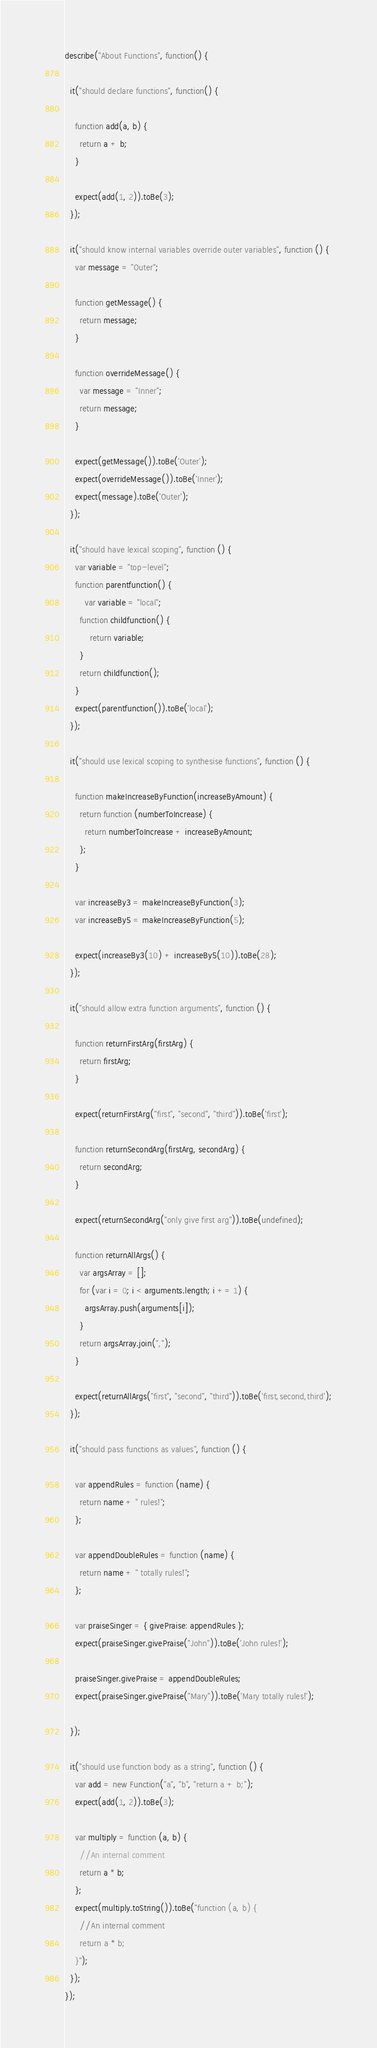Convert code to text. <code><loc_0><loc_0><loc_500><loc_500><_JavaScript_>describe("About Functions", function() {

  it("should declare functions", function() {
    
    function add(a, b) {
      return a + b;
    }
    
    expect(add(1, 2)).toBe(3);
  });

  it("should know internal variables override outer variables", function () {
    var message = "Outer";
    
    function getMessage() {
      return message;
    }
    
    function overrideMessage() {
      var message = "Inner";
      return message;
    }
    
    expect(getMessage()).toBe('Outer');
    expect(overrideMessage()).toBe('Inner');
    expect(message).toBe('Outer');
  });

  it("should have lexical scoping", function () {
    var variable = "top-level";
    function parentfunction() {
        var variable = "local";
      function childfunction() {
          return variable;
      }
      return childfunction();
    }
    expect(parentfunction()).toBe('local');
  });

  it("should use lexical scoping to synthesise functions", function () {
    
    function makeIncreaseByFunction(increaseByAmount) {
      return function (numberToIncrease) {
        return numberToIncrease + increaseByAmount;
      };
    }
    
    var increaseBy3 = makeIncreaseByFunction(3);
    var increaseBy5 = makeIncreaseByFunction(5);
    
    expect(increaseBy3(10) + increaseBy5(10)).toBe(28);
  });

  it("should allow extra function arguments", function () {
    
    function returnFirstArg(firstArg) {
      return firstArg;
    }
    
    expect(returnFirstArg("first", "second", "third")).toBe('first');
    
    function returnSecondArg(firstArg, secondArg) {
      return secondArg;
    }
    
    expect(returnSecondArg("only give first arg")).toBe(undefined);
    
    function returnAllArgs() {
      var argsArray = [];
      for (var i = 0; i < arguments.length; i += 1) {
        argsArray.push(arguments[i]);
      }
      return argsArray.join(",");
    }
    
    expect(returnAllArgs("first", "second", "third")).toBe('first,second,third');
  });

  it("should pass functions as values", function () {

    var appendRules = function (name) {
      return name + " rules!";
    };
    
    var appendDoubleRules = function (name) {
      return name + " totally rules!";
    };
    
    var praiseSinger = { givePraise: appendRules };
    expect(praiseSinger.givePraise("John")).toBe('John rules!');
    
    praiseSinger.givePraise = appendDoubleRules;
    expect(praiseSinger.givePraise("Mary")).toBe('Mary totally rules!');
      
  });

  it("should use function body as a string", function () {
    var add = new Function("a", "b", "return a + b;");
    expect(add(1, 2)).toBe(3);
     
    var multiply = function (a, b) {
      //An internal comment
      return a * b;
    };
    expect(multiply.toString()).toBe("function (a, b) {
      //An internal comment
      return a * b;
    }");
  });    
});
</code> 